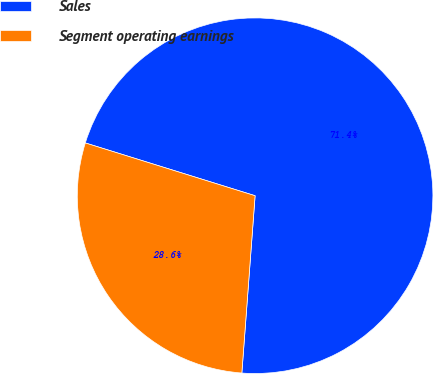<chart> <loc_0><loc_0><loc_500><loc_500><pie_chart><fcel>Sales<fcel>Segment operating earnings<nl><fcel>71.39%<fcel>28.61%<nl></chart> 